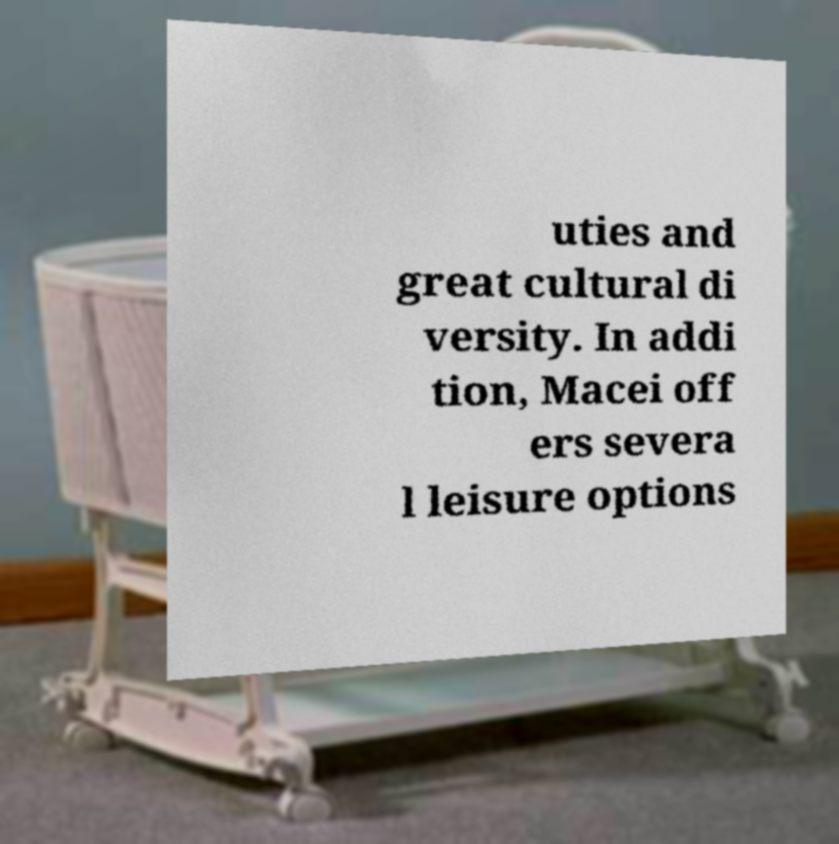Please read and relay the text visible in this image. What does it say? uties and great cultural di versity. In addi tion, Macei off ers severa l leisure options 